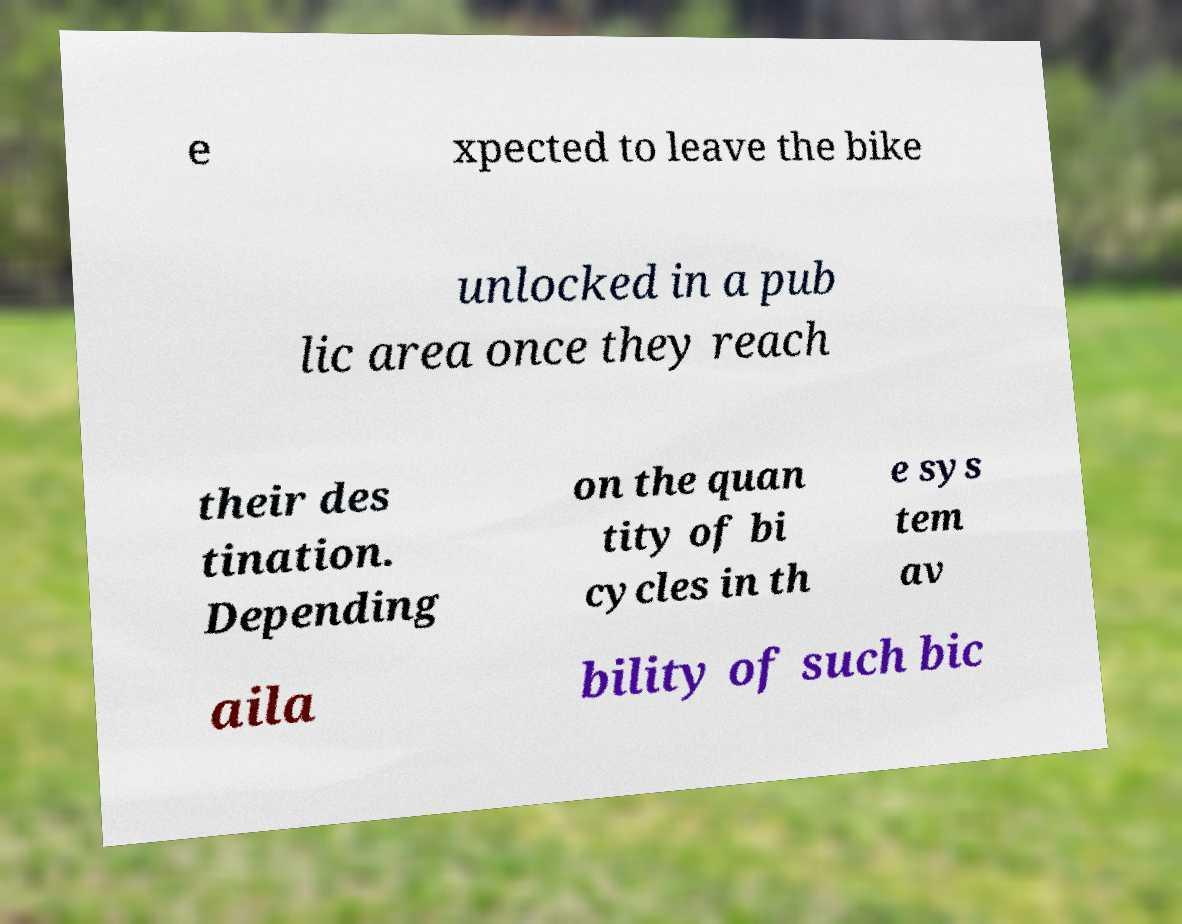Could you extract and type out the text from this image? e xpected to leave the bike unlocked in a pub lic area once they reach their des tination. Depending on the quan tity of bi cycles in th e sys tem av aila bility of such bic 